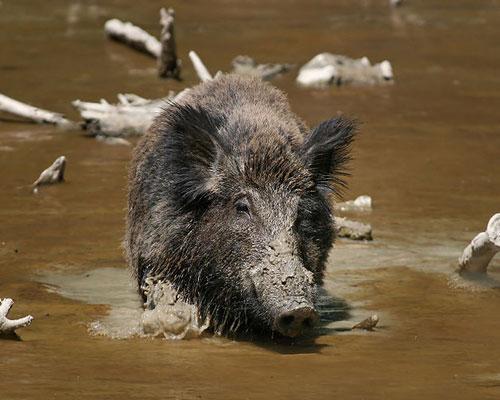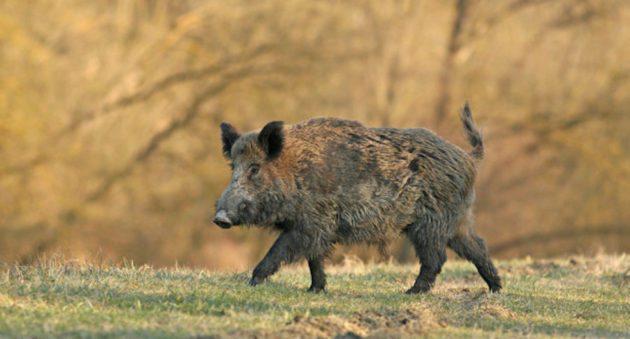The first image is the image on the left, the second image is the image on the right. Given the left and right images, does the statement "An image contains a single boar wading through water." hold true? Answer yes or no. Yes. The first image is the image on the left, the second image is the image on the right. Assess this claim about the two images: "One image shows a wild pig wading in brown water". Correct or not? Answer yes or no. Yes. 